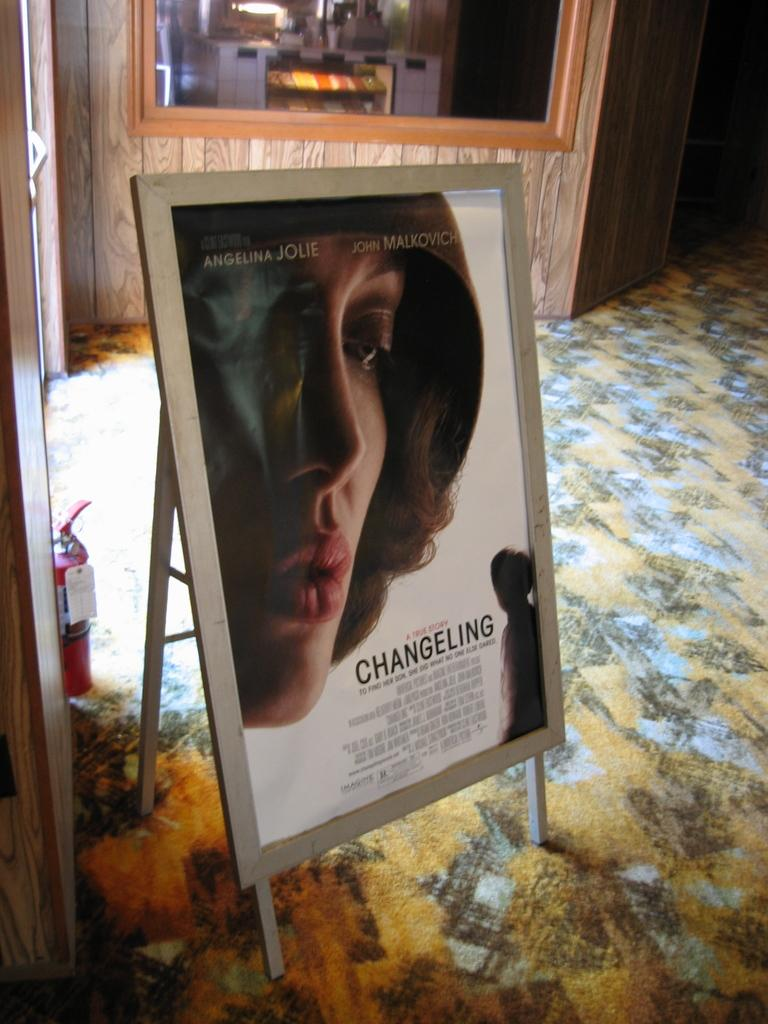What is on the board that is visible in the image? There is a picture and text on the board in the image. What safety device can be seen in the image? There is a fire extinguisher in the image. What type of flooring is present in the image? There is a carpet on the floor in the image. What type of door is visible in the image? There is a glass door visible in the image. What number is written on the lamp in the image? There is no lamp present in the image, so it is not possible to determine any numbers written on it. 